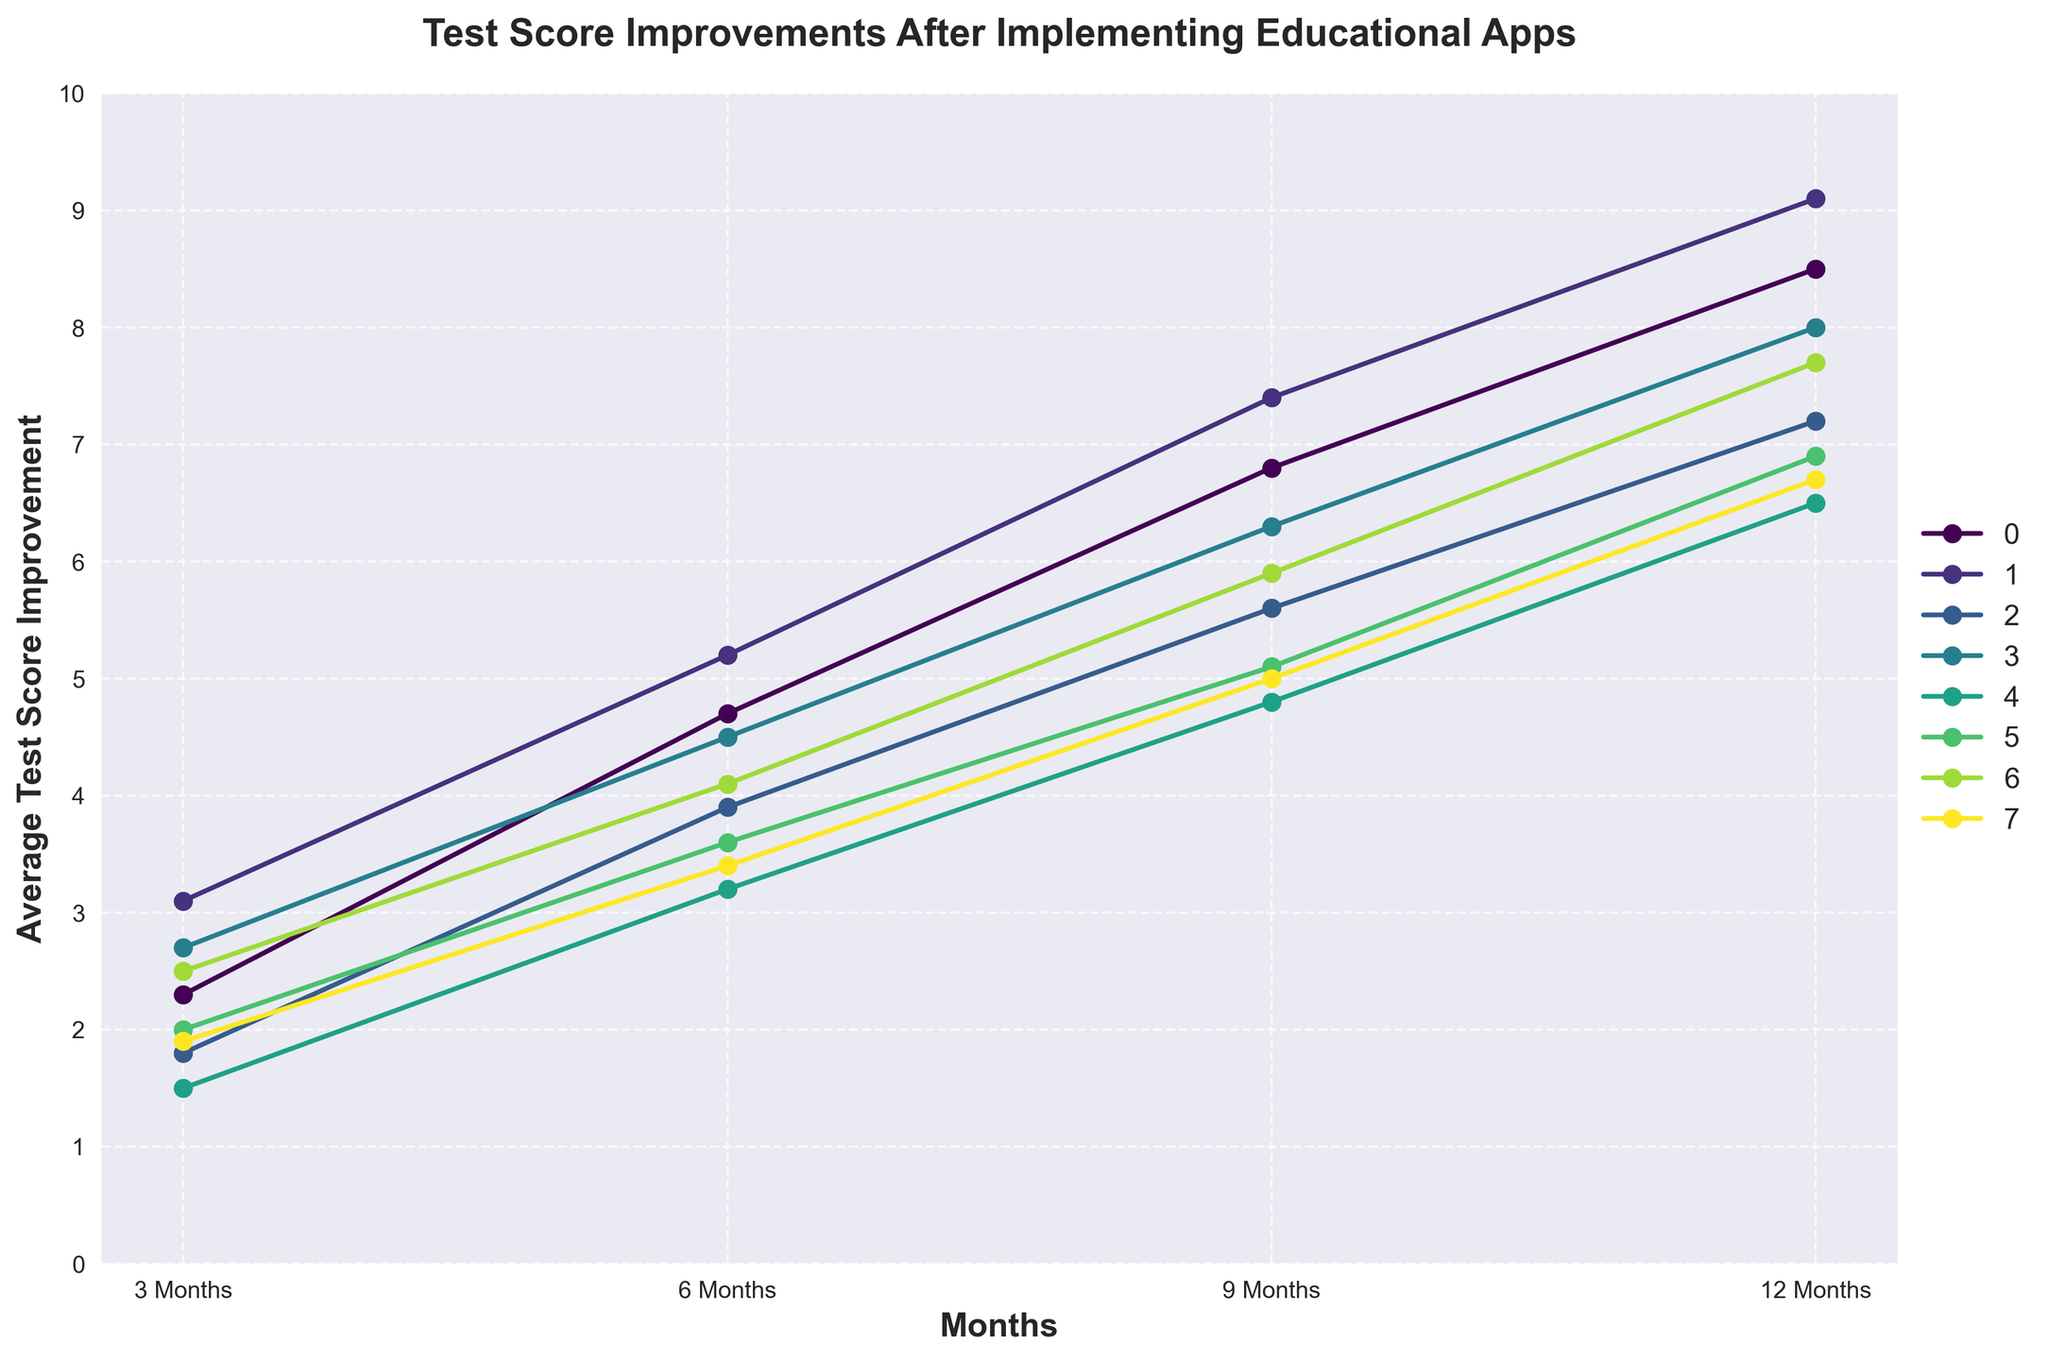What subject shows the highest average test score improvement after 12 months? The subject "Reading Comprehension" shows the highest average test score improvement after 12 months since its value is 9.1, which is the highest among all subjects.
Answer: Reading Comprehension By how many points does Vocabulary improve after 6 months compared to 3 months? Vocabulary improvement after 6 months is 4.5 and after 3 months is 2.7. Subtracting these two values, 4.5 - 2.7, gives us the improvement.
Answer: 1.8 What is the average improvement across all subjects after 9 months? To find the average improvement after 9 months, add all the scores after 9 months and divide by the number of subjects: (6.8 + 7.4 + 5.6 + 6.3 + 4.8 + 5.1 + 5.9 + 5.0) / 8.
Answer: 5.99 Which subject shows the least improvement after 3 months? The subject "Critical Thinking" shows the least improvement after 3 months since it has the lowest value of 1.5 among all subjects.
Answer: Critical Thinking Is the improvement in Mathematics always increasing over the months? Yes, Mathematics shows an increasing improvement: 2.3 at 3 months, 4.7 at 6 months, 6.8 at 9 months, and 8.5 at 12 months. This indicates a consistent increase over time.
Answer: Yes Does Science ever improve more than Critical Thinking over any time period? Yes, Science always shows higher values in every time period compared to Critical Thinking: 1.8 > 1.5 at 3 months, 3.9 > 3.2 at 6 months, 5.6 > 4.8 at 9 months, and 7.2 > 6.5 at 12 months.
Answer: Yes How much total improvement did Creative Writing show after 12 months compared to 3 months? Creative Writing improved from 1.9 at 3 months to 6.7 at 12 months. Subtracting these values, 6.7 - 1.9, gives us the total improvement.
Answer: 4.8 Which two subjects had nearly similar improvements at any month interval? Mathematics and Foreign Language had nearly similar improvements at the 3-month mark: Mathematics 2.3 and Foreign Language 2.5, a difference of just 0.2 points.
Answer: Mathematics and Foreign Language How does the overall trend look for History from 3 to 12 months? History shows a consistent increase over each time period: starting from 2.0 at 3 months, 3.6 at 6 months, 5.1 at 9 months, to 6.9 at 12 months. This indicates a steady upward trend.
Answer: Steady upward What is the difference in average score improvement between Science and Critical Thinking after 12 months? Science has an improvement of 7.2 at 12 months and Critical Thinking has 6.5. Subtracting these, 7.2 - 6.5, we find the difference.
Answer: 0.7 